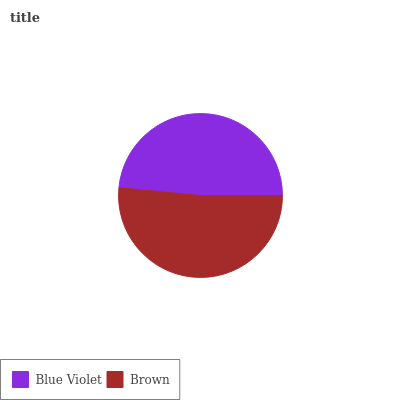Is Blue Violet the minimum?
Answer yes or no. Yes. Is Brown the maximum?
Answer yes or no. Yes. Is Brown the minimum?
Answer yes or no. No. Is Brown greater than Blue Violet?
Answer yes or no. Yes. Is Blue Violet less than Brown?
Answer yes or no. Yes. Is Blue Violet greater than Brown?
Answer yes or no. No. Is Brown less than Blue Violet?
Answer yes or no. No. Is Brown the high median?
Answer yes or no. Yes. Is Blue Violet the low median?
Answer yes or no. Yes. Is Blue Violet the high median?
Answer yes or no. No. Is Brown the low median?
Answer yes or no. No. 